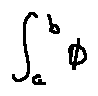<formula> <loc_0><loc_0><loc_500><loc_500>\int \lim i t s _ { a } ^ { b } \phi</formula> 